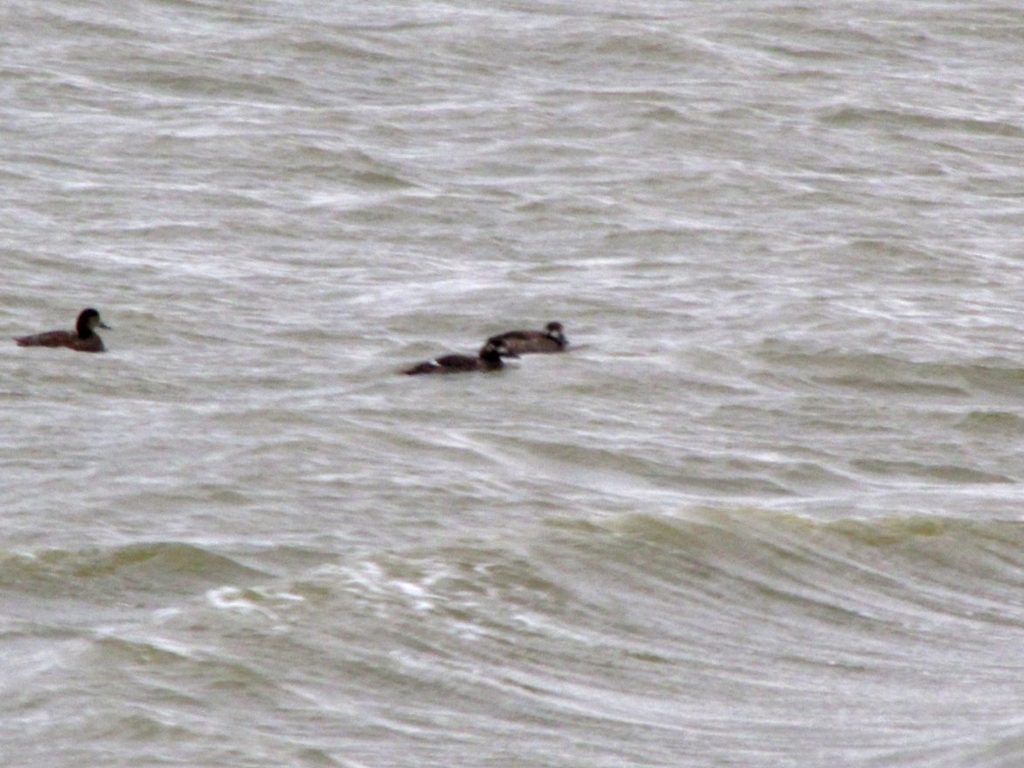What is the overall quality of this image? The overall quality of this image is below average due to its lack of sharpness and clear subject focus. The elements in the photo, such as the ducks and the rippling water, are not well-defined, which affects the image's clarity and visual appeal. 